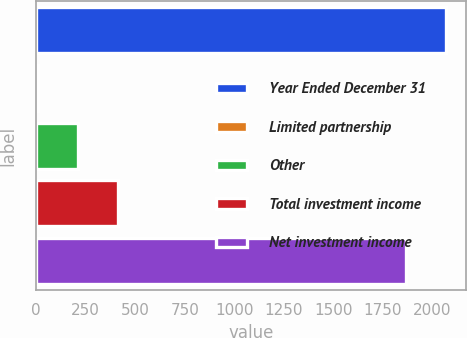<chart> <loc_0><loc_0><loc_500><loc_500><bar_chart><fcel>Year Ended December 31<fcel>Limited partnership<fcel>Other<fcel>Total investment income<fcel>Net investment income<nl><fcel>2066.4<fcel>11<fcel>211.4<fcel>411.8<fcel>1866<nl></chart> 